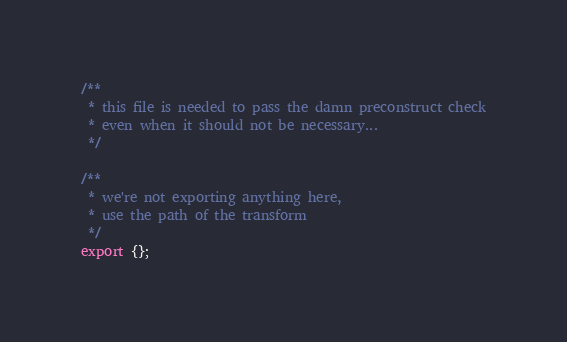Convert code to text. <code><loc_0><loc_0><loc_500><loc_500><_TypeScript_>/**
 * this file is needed to pass the damn preconstruct check
 * even when it should not be necessary...
 */

/**
 * we're not exporting anything here,
 * use the path of the transform
 */
export {};
</code> 